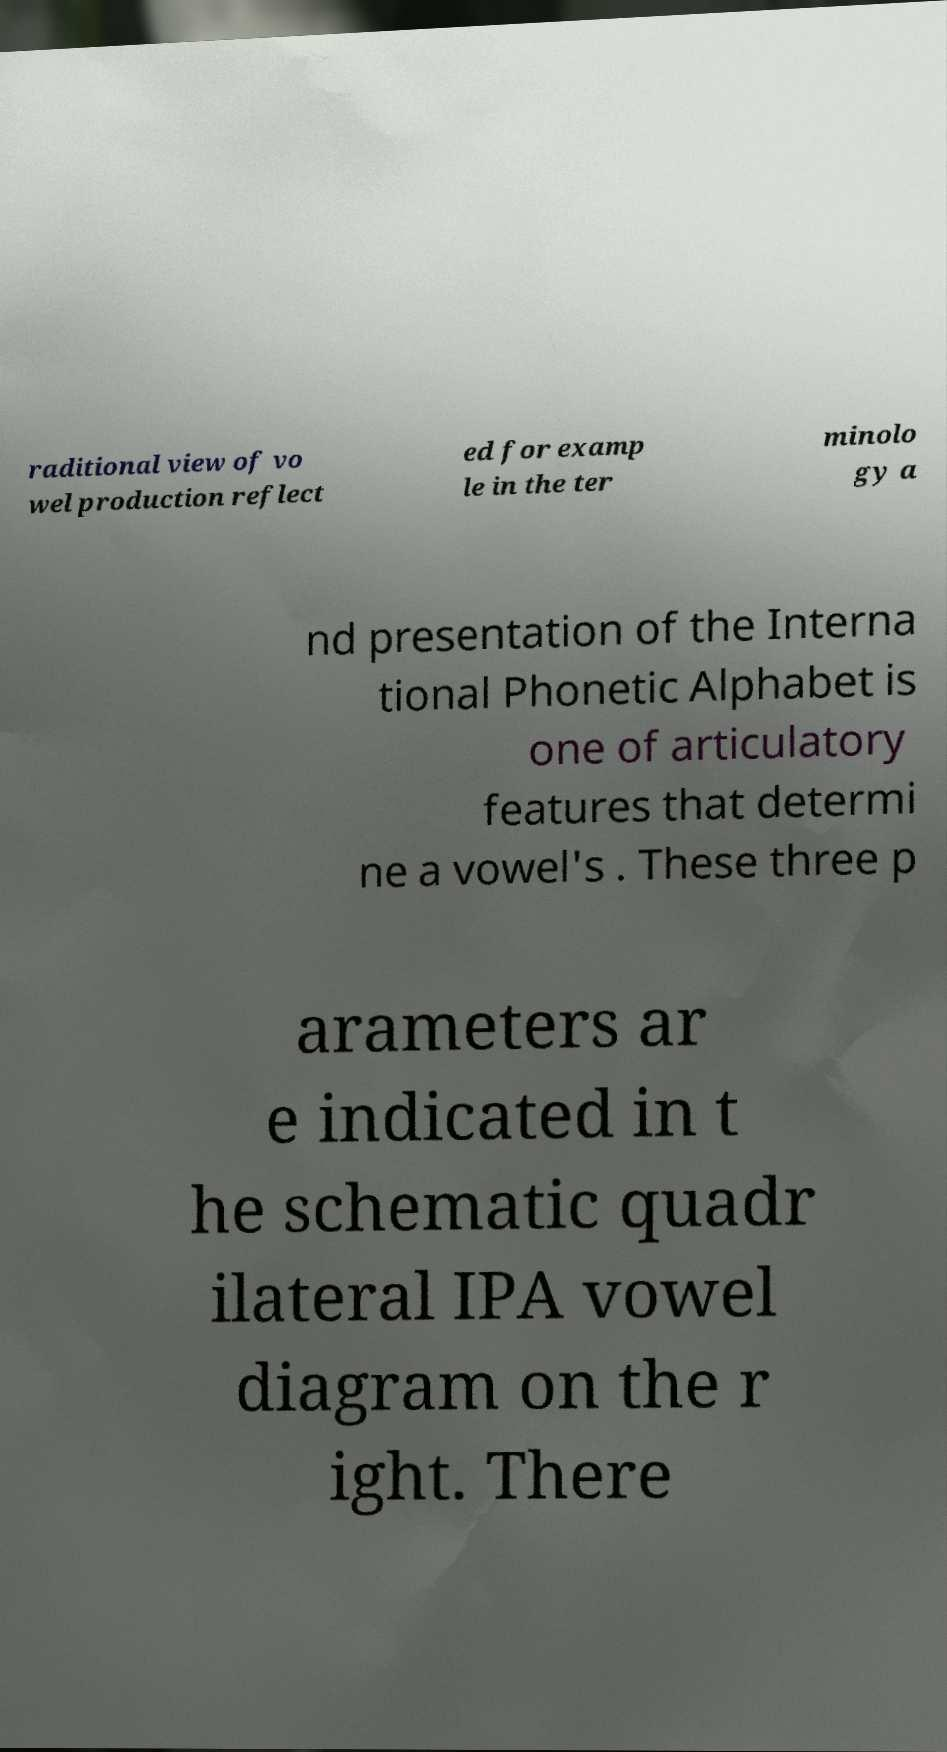Can you accurately transcribe the text from the provided image for me? raditional view of vo wel production reflect ed for examp le in the ter minolo gy a nd presentation of the Interna tional Phonetic Alphabet is one of articulatory features that determi ne a vowel's . These three p arameters ar e indicated in t he schematic quadr ilateral IPA vowel diagram on the r ight. There 